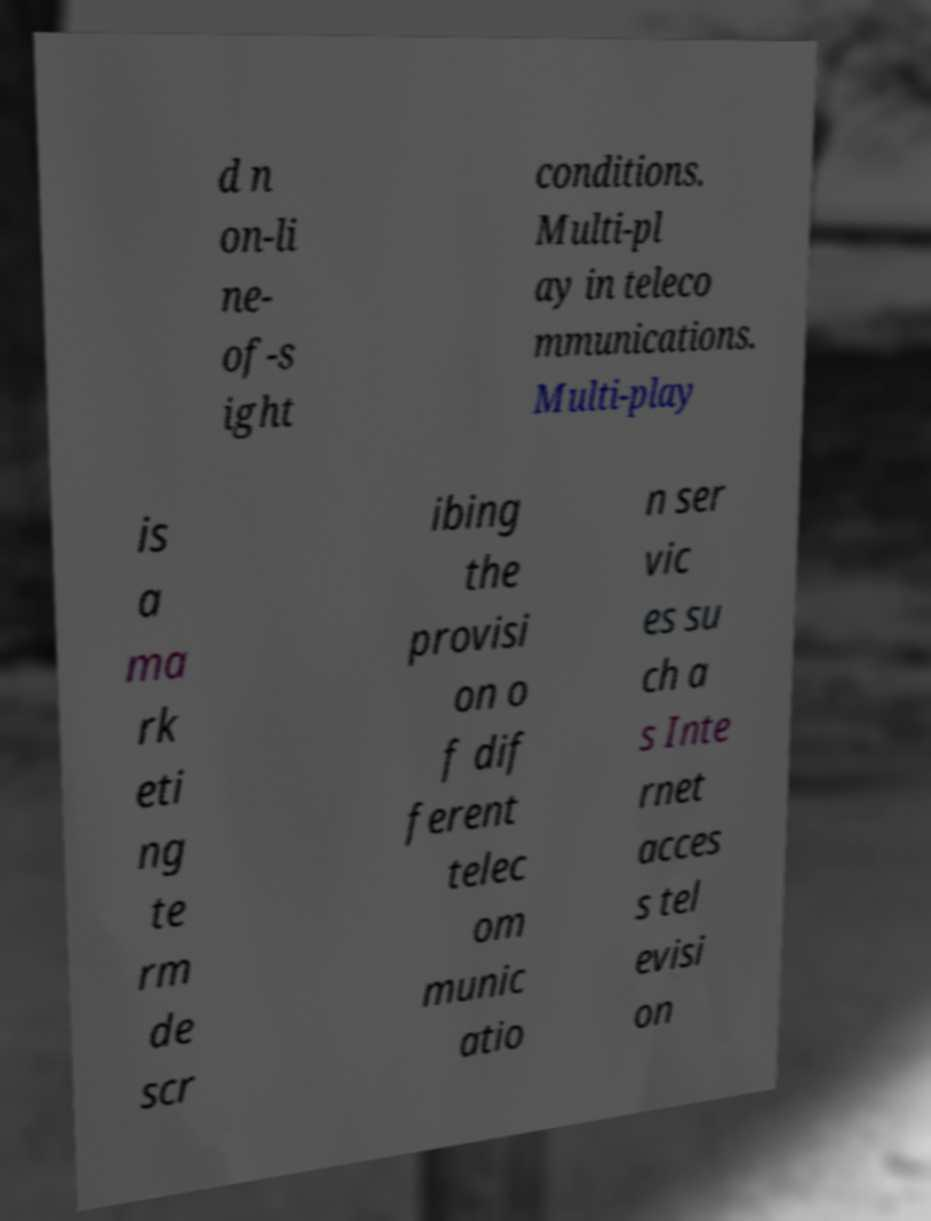Please read and relay the text visible in this image. What does it say? d n on-li ne- of-s ight conditions. Multi-pl ay in teleco mmunications. Multi-play is a ma rk eti ng te rm de scr ibing the provisi on o f dif ferent telec om munic atio n ser vic es su ch a s Inte rnet acces s tel evisi on 